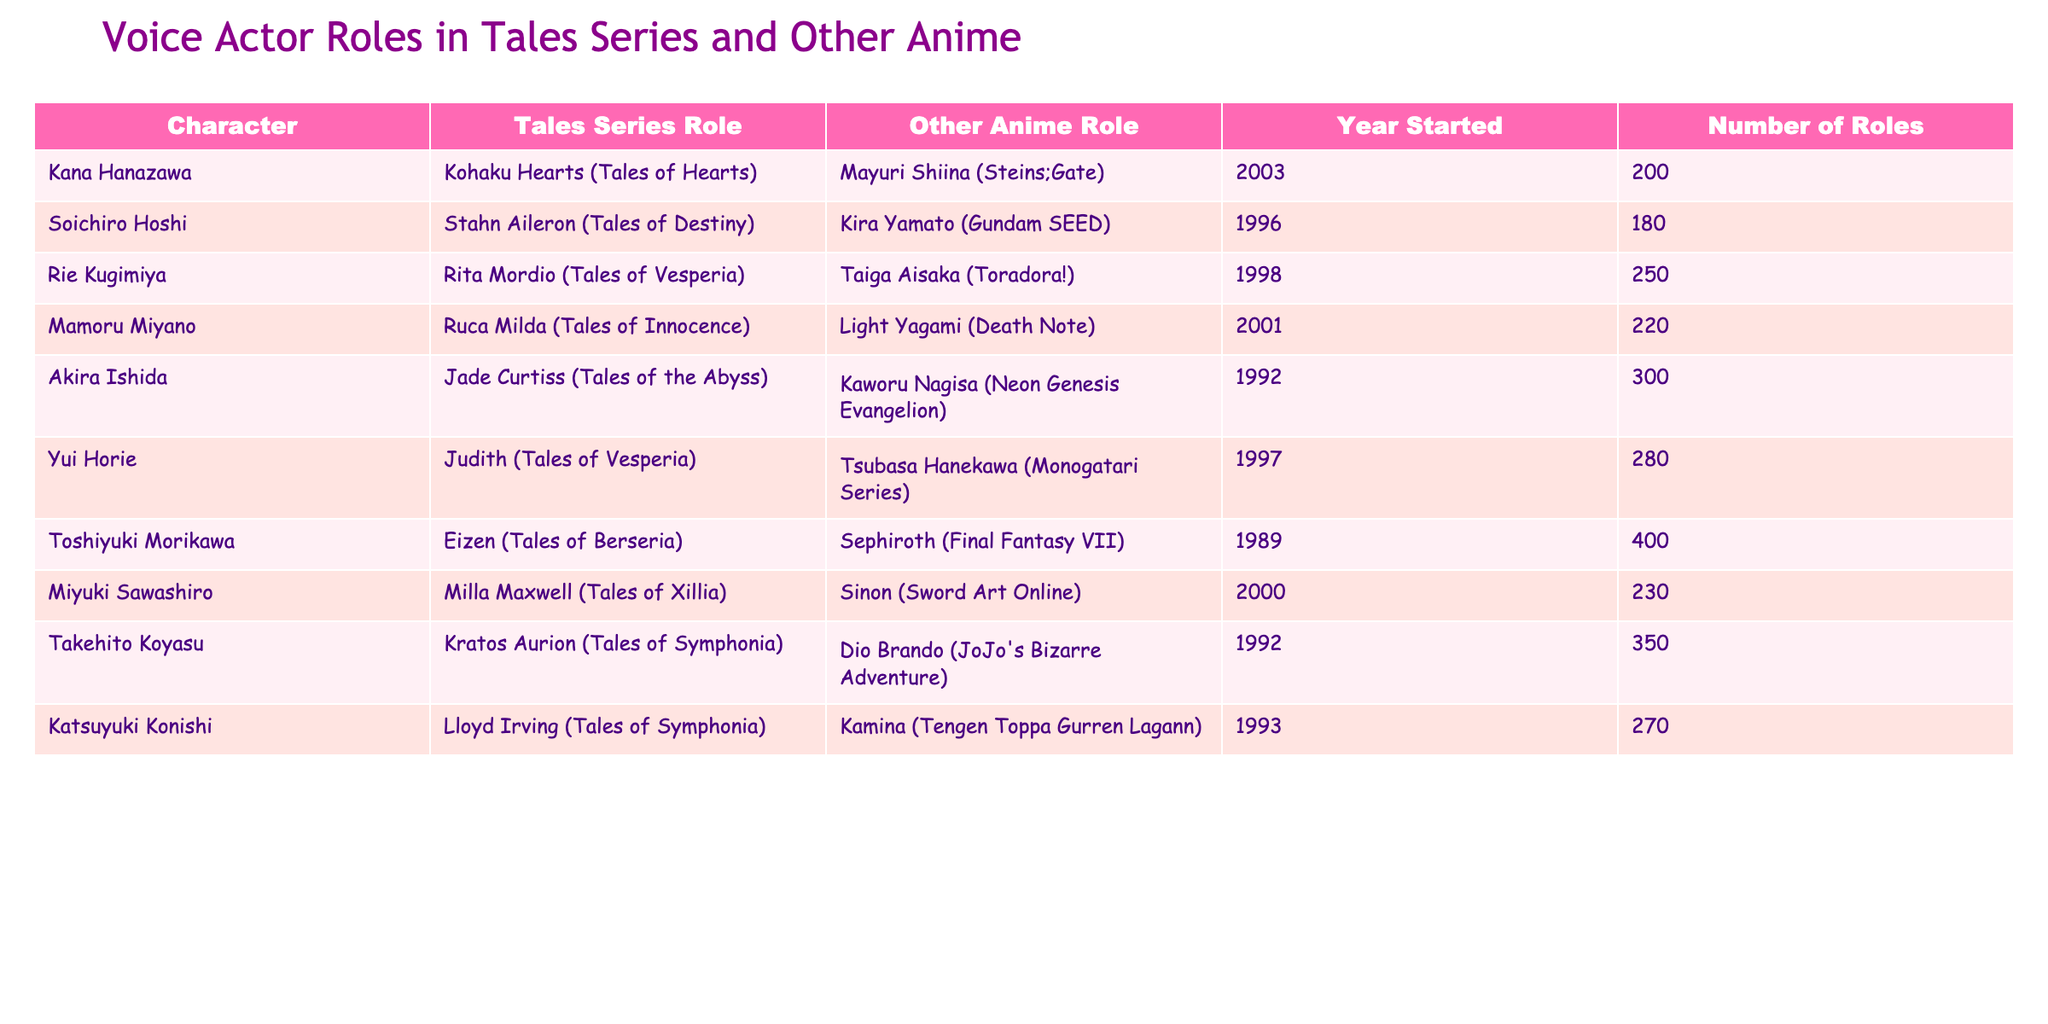What role did Mamoru Miyano play in the Tales series? The table shows that Mamoru Miyano voiced Ruca Milda in Tales of Innocence.
Answer: Ruca Milda Who has the most voice acting roles among the listed actors? By comparing the "Number of Roles" column, Toshiyuki Morikawa has the highest value at 400.
Answer: Toshiyuki Morikawa Is Kana Hanazawa involved in the same year for both roles? Kana Hanazawa’s roles started in 2003, and she voices both Kohaku Hearts and Mayuri Shiina in that year, confirming she is involved in both roles in the same year.
Answer: Yes Which character did Akira Ishida voice in the Tales series? According to the table, Akira Ishida voiced Jade Curtiss in Tales of the Abyss.
Answer: Jade Curtiss What is the total number of roles held by Soichiro Hoshi and Rie Kugimiya combined? The sum of their roles is 180 (Soichiro Hoshi) + 250 (Rie Kugimiya) = 430.
Answer: 430 Who voiced a character in both the Tales series and Gundam SEED? Soichiro Hoshi voiced Stahn Aileron in the Tales series and Kira Yamato in Gundam SEED, confirming he voiced in both.
Answer: Soichiro Hoshi Are there any voice actors who have roles in Tales series starting from the year 1997? The table shows Yui Horie (1997) and Katsuyuki Konishi (1993) with involvement in the Tales series, confirming yes, there are actors.
Answer: Yes How many more roles does Mamoru Miyano have compared to Kana Hanazawa? Mamoru Miyano has 220 roles, while Kana Hanazawa has 200 roles, resulting in a difference of 20 roles.
Answer: 20 What is the median number of roles for the actors listed? The sorted number of roles is 180, 200, 220, 230, 250, 270, 280, 300, 350, 400. The middle values are 230 and 250, so the median is (230 + 250) / 2 = 240.
Answer: 240 Which voice actor has the least number of roles and what is the number? The table indicates Soichiro Hoshi has the least number of roles at 180.
Answer: 180 